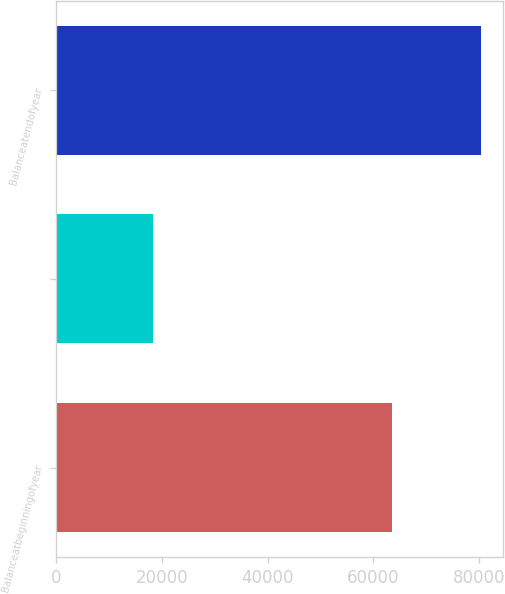Convert chart to OTSL. <chart><loc_0><loc_0><loc_500><loc_500><bar_chart><fcel>Balanceatbeginningofyear<fcel>Unnamed: 1<fcel>Balanceatendofyear<nl><fcel>63549<fcel>18259.2<fcel>80388<nl></chart> 